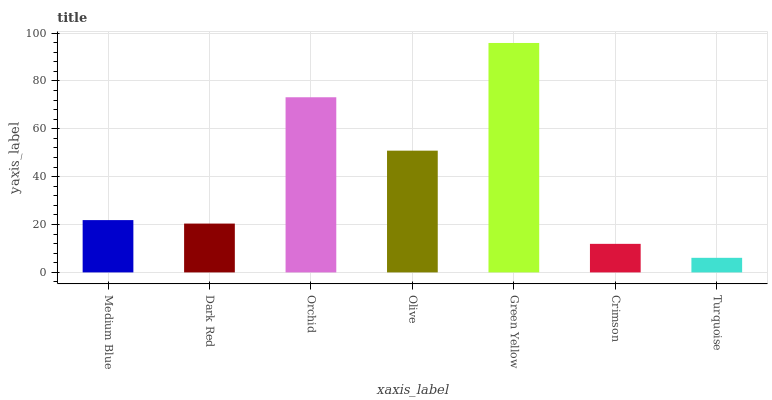Is Turquoise the minimum?
Answer yes or no. Yes. Is Green Yellow the maximum?
Answer yes or no. Yes. Is Dark Red the minimum?
Answer yes or no. No. Is Dark Red the maximum?
Answer yes or no. No. Is Medium Blue greater than Dark Red?
Answer yes or no. Yes. Is Dark Red less than Medium Blue?
Answer yes or no. Yes. Is Dark Red greater than Medium Blue?
Answer yes or no. No. Is Medium Blue less than Dark Red?
Answer yes or no. No. Is Medium Blue the high median?
Answer yes or no. Yes. Is Medium Blue the low median?
Answer yes or no. Yes. Is Turquoise the high median?
Answer yes or no. No. Is Green Yellow the low median?
Answer yes or no. No. 